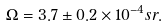<formula> <loc_0><loc_0><loc_500><loc_500>\Omega = 3 . 7 \pm 0 . 2 \times 1 0 ^ { - 4 } s r .</formula> 